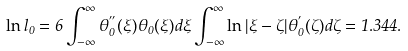Convert formula to latex. <formula><loc_0><loc_0><loc_500><loc_500>\ln l _ { 0 } = 6 \int _ { - \infty } ^ { \infty } \theta _ { 0 } ^ { ^ { \prime \prime } } ( \xi ) \theta _ { 0 } ( \xi ) d \xi \int _ { - \infty } ^ { \infty } \ln | \xi - \zeta | \theta _ { 0 } ^ { ^ { \prime } } ( \zeta ) d \zeta = 1 . 3 4 4 .</formula> 